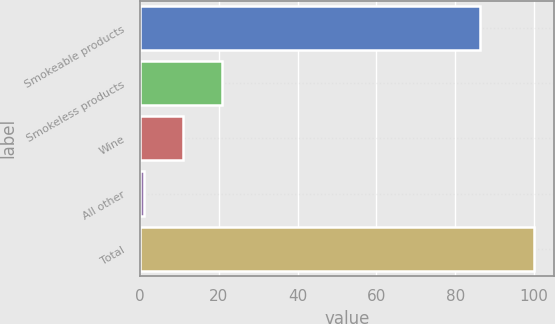Convert chart to OTSL. <chart><loc_0><loc_0><loc_500><loc_500><bar_chart><fcel>Smokeable products<fcel>Smokeless products<fcel>Wine<fcel>All other<fcel>Total<nl><fcel>86.2<fcel>20.88<fcel>10.99<fcel>1.1<fcel>100<nl></chart> 